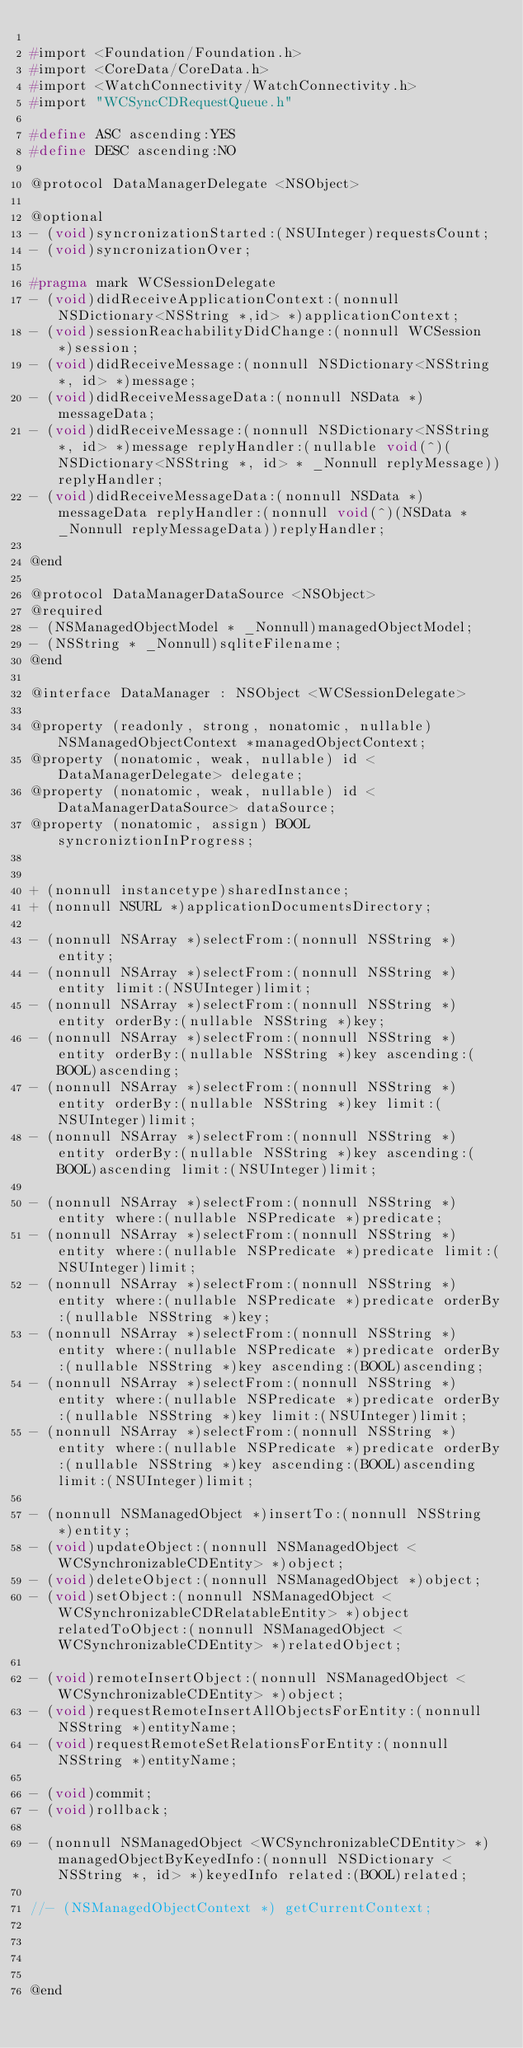<code> <loc_0><loc_0><loc_500><loc_500><_C_>
#import <Foundation/Foundation.h>
#import <CoreData/CoreData.h>
#import <WatchConnectivity/WatchConnectivity.h>
#import "WCSyncCDRequestQueue.h"

#define ASC ascending:YES
#define DESC ascending:NO

@protocol DataManagerDelegate <NSObject>

@optional
- (void)syncronizationStarted:(NSUInteger)requestsCount;
- (void)syncronizationOver;

#pragma mark WCSessionDelegate
- (void)didReceiveApplicationContext:(nonnull NSDictionary<NSString *,id> *)applicationContext;
- (void)sessionReachabilityDidChange:(nonnull WCSession *)session;
- (void)didReceiveMessage:(nonnull NSDictionary<NSString *, id> *)message;
- (void)didReceiveMessageData:(nonnull NSData *)messageData;
- (void)didReceiveMessage:(nonnull NSDictionary<NSString *, id> *)message replyHandler:(nullable void(^)(NSDictionary<NSString *, id> * _Nonnull replyMessage))replyHandler;
- (void)didReceiveMessageData:(nonnull NSData *)messageData replyHandler:(nonnull void(^)(NSData * _Nonnull replyMessageData))replyHandler;

@end

@protocol DataManagerDataSource <NSObject>
@required
- (NSManagedObjectModel * _Nonnull)managedObjectModel;
- (NSString * _Nonnull)sqliteFilename;
@end

@interface DataManager : NSObject <WCSessionDelegate>

@property (readonly, strong, nonatomic, nullable) NSManagedObjectContext *managedObjectContext;
@property (nonatomic, weak, nullable) id <DataManagerDelegate> delegate;
@property (nonatomic, weak, nullable) id <DataManagerDataSource> dataSource;
@property (nonatomic, assign) BOOL syncroniztionInProgress;


+ (nonnull instancetype)sharedInstance;
+ (nonnull NSURL *)applicationDocumentsDirectory;

- (nonnull NSArray *)selectFrom:(nonnull NSString *)entity;
- (nonnull NSArray *)selectFrom:(nonnull NSString *)entity limit:(NSUInteger)limit;
- (nonnull NSArray *)selectFrom:(nonnull NSString *)entity orderBy:(nullable NSString *)key;
- (nonnull NSArray *)selectFrom:(nonnull NSString *)entity orderBy:(nullable NSString *)key ascending:(BOOL)ascending;
- (nonnull NSArray *)selectFrom:(nonnull NSString *)entity orderBy:(nullable NSString *)key limit:(NSUInteger)limit;
- (nonnull NSArray *)selectFrom:(nonnull NSString *)entity orderBy:(nullable NSString *)key ascending:(BOOL)ascending limit:(NSUInteger)limit;

- (nonnull NSArray *)selectFrom:(nonnull NSString *)entity where:(nullable NSPredicate *)predicate;
- (nonnull NSArray *)selectFrom:(nonnull NSString *)entity where:(nullable NSPredicate *)predicate limit:(NSUInteger)limit;
- (nonnull NSArray *)selectFrom:(nonnull NSString *)entity where:(nullable NSPredicate *)predicate orderBy:(nullable NSString *)key;
- (nonnull NSArray *)selectFrom:(nonnull NSString *)entity where:(nullable NSPredicate *)predicate orderBy:(nullable NSString *)key ascending:(BOOL)ascending;
- (nonnull NSArray *)selectFrom:(nonnull NSString *)entity where:(nullable NSPredicate *)predicate orderBy:(nullable NSString *)key limit:(NSUInteger)limit;
- (nonnull NSArray *)selectFrom:(nonnull NSString *)entity where:(nullable NSPredicate *)predicate orderBy:(nullable NSString *)key ascending:(BOOL)ascending limit:(NSUInteger)limit;

- (nonnull NSManagedObject *)insertTo:(nonnull NSString *)entity;
- (void)updateObject:(nonnull NSManagedObject <WCSynchronizableCDEntity> *)object;
- (void)deleteObject:(nonnull NSManagedObject *)object;
- (void)setObject:(nonnull NSManagedObject <WCSynchronizableCDRelatableEntity> *)object relatedToObject:(nonnull NSManagedObject <WCSynchronizableCDEntity> *)relatedObject;

- (void)remoteInsertObject:(nonnull NSManagedObject <WCSynchronizableCDEntity> *)object;
- (void)requestRemoteInsertAllObjectsForEntity:(nonnull NSString *)entityName;
- (void)requestRemoteSetRelationsForEntity:(nonnull NSString *)entityName;

- (void)commit;
- (void)rollback;

- (nonnull NSManagedObject <WCSynchronizableCDEntity> *)managedObjectByKeyedInfo:(nonnull NSDictionary <NSString *, id> *)keyedInfo related:(BOOL)related;

//- (NSManagedObjectContext *) getCurrentContext;




@end
</code> 